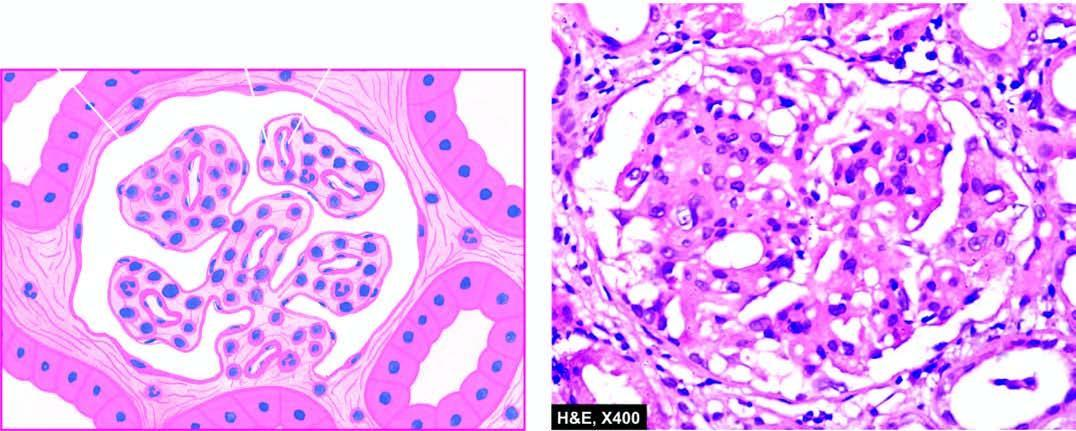s there widespread thickening of the gbm?
Answer the question using a single word or phrase. Yes 